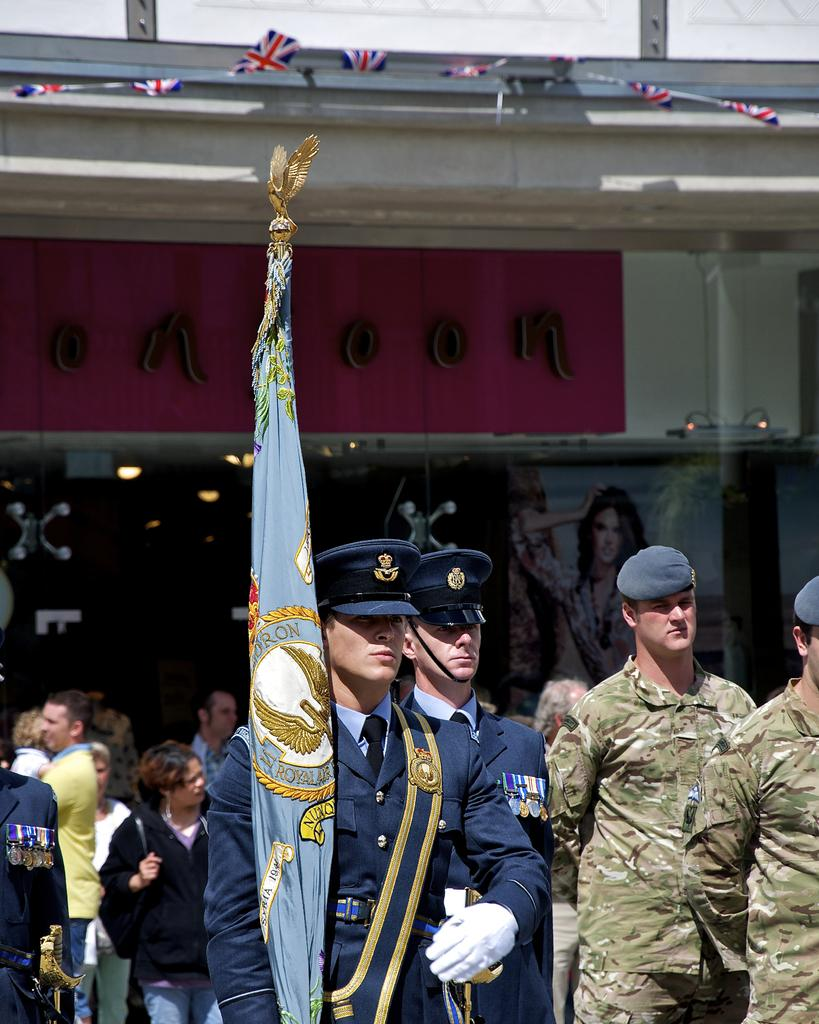Who or what can be seen in the image? There are people in the image. What structure is visible in the image? There is a building in the image. What is the man in the image doing? A man is holding a flag in the image. How many geese are visible in the image? There are no geese present in the image. What type of debt is being discussed by the people in the image? There is no indication of any debt being discussed in the image. 